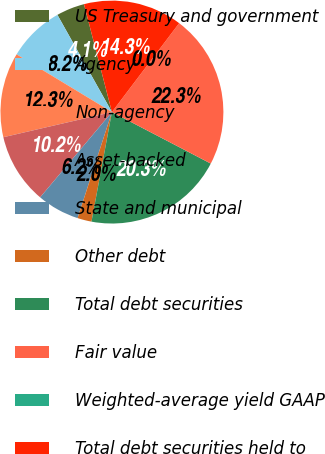Convert chart. <chart><loc_0><loc_0><loc_500><loc_500><pie_chart><fcel>US Treasury and government<fcel>Agency<fcel>Non-agency<fcel>Asset-backed<fcel>State and municipal<fcel>Other debt<fcel>Total debt securities<fcel>Fair value<fcel>Weighted-average yield GAAP<fcel>Total debt securities held to<nl><fcel>4.1%<fcel>8.2%<fcel>12.29%<fcel>10.24%<fcel>6.15%<fcel>2.05%<fcel>20.29%<fcel>22.34%<fcel>0.0%<fcel>14.34%<nl></chart> 